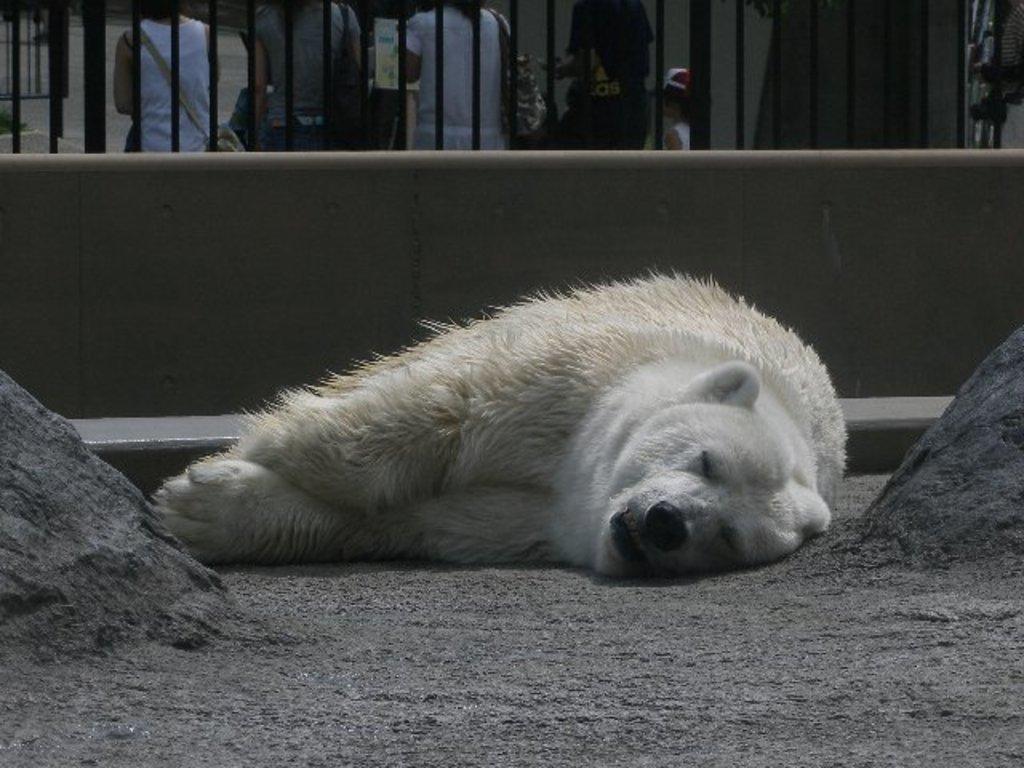How would you summarize this image in a sentence or two? In this picture we can observe white color polar bear sleeping on the land. We can observe a black color railing. In the background there are some people. 